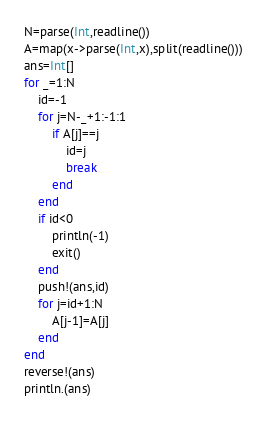Convert code to text. <code><loc_0><loc_0><loc_500><loc_500><_Julia_>N=parse(Int,readline())
A=map(x->parse(Int,x),split(readline()))
ans=Int[]
for _=1:N
	id=-1
	for j=N-_+1:-1:1
		if A[j]==j
			id=j
			break
		end
	end
	if id<0
		println(-1)
		exit()
	end
	push!(ans,id)
	for j=id+1:N
		A[j-1]=A[j]
	end
end
reverse!(ans)
println.(ans)
</code> 